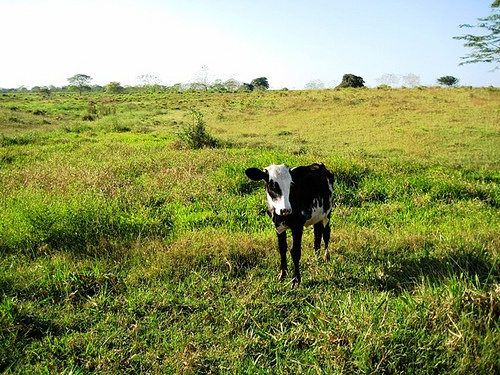Describe the objects in this image and their specific colors. I can see a cow in white, black, gray, darkgray, and darkgreen tones in this image. 